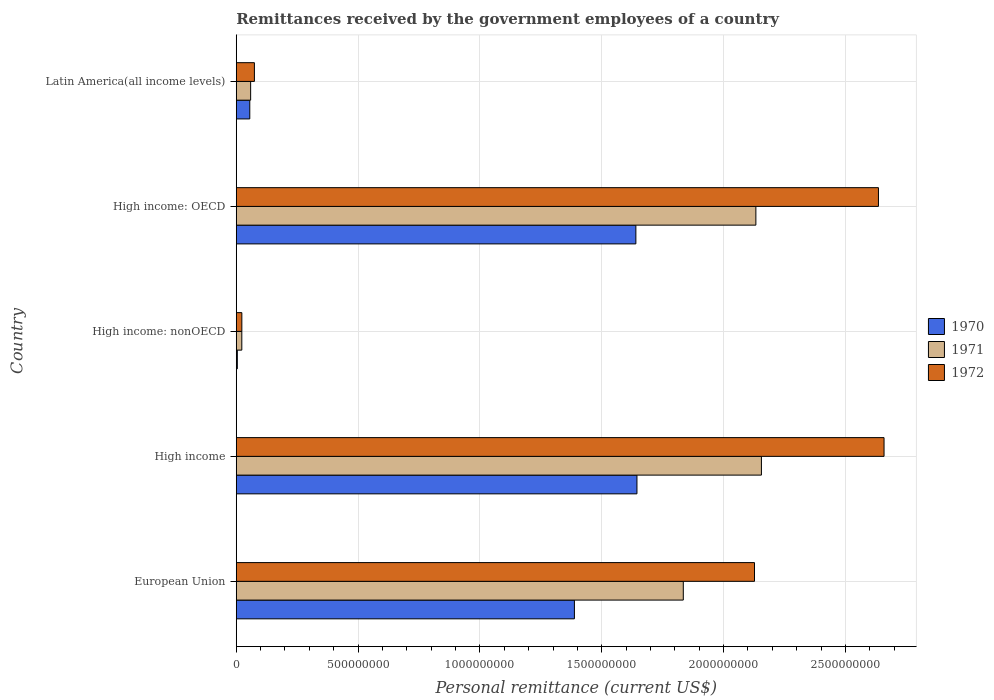How many groups of bars are there?
Provide a short and direct response. 5. Are the number of bars per tick equal to the number of legend labels?
Keep it short and to the point. Yes. How many bars are there on the 2nd tick from the top?
Your answer should be compact. 3. How many bars are there on the 5th tick from the bottom?
Provide a short and direct response. 3. In how many cases, is the number of bars for a given country not equal to the number of legend labels?
Ensure brevity in your answer.  0. What is the remittances received by the government employees in 1971 in Latin America(all income levels)?
Offer a very short reply. 5.91e+07. Across all countries, what is the maximum remittances received by the government employees in 1971?
Offer a very short reply. 2.16e+09. Across all countries, what is the minimum remittances received by the government employees in 1972?
Offer a very short reply. 2.29e+07. In which country was the remittances received by the government employees in 1971 maximum?
Offer a terse response. High income. In which country was the remittances received by the government employees in 1972 minimum?
Give a very brief answer. High income: nonOECD. What is the total remittances received by the government employees in 1971 in the graph?
Make the answer very short. 6.20e+09. What is the difference between the remittances received by the government employees in 1970 in High income and that in Latin America(all income levels)?
Provide a short and direct response. 1.59e+09. What is the difference between the remittances received by the government employees in 1970 in High income and the remittances received by the government employees in 1971 in Latin America(all income levels)?
Offer a terse response. 1.59e+09. What is the average remittances received by the government employees in 1971 per country?
Ensure brevity in your answer.  1.24e+09. What is the difference between the remittances received by the government employees in 1972 and remittances received by the government employees in 1970 in High income: OECD?
Give a very brief answer. 9.96e+08. What is the ratio of the remittances received by the government employees in 1972 in High income to that in Latin America(all income levels)?
Your answer should be very brief. 35.7. Is the difference between the remittances received by the government employees in 1972 in European Union and Latin America(all income levels) greater than the difference between the remittances received by the government employees in 1970 in European Union and Latin America(all income levels)?
Provide a short and direct response. Yes. What is the difference between the highest and the second highest remittances received by the government employees in 1972?
Give a very brief answer. 2.29e+07. What is the difference between the highest and the lowest remittances received by the government employees in 1972?
Give a very brief answer. 2.64e+09. Is the sum of the remittances received by the government employees in 1971 in High income and High income: OECD greater than the maximum remittances received by the government employees in 1972 across all countries?
Make the answer very short. Yes. What does the 1st bar from the bottom in European Union represents?
Offer a terse response. 1970. Is it the case that in every country, the sum of the remittances received by the government employees in 1972 and remittances received by the government employees in 1971 is greater than the remittances received by the government employees in 1970?
Give a very brief answer. Yes. How many bars are there?
Offer a very short reply. 15. Are all the bars in the graph horizontal?
Your answer should be compact. Yes. How many countries are there in the graph?
Offer a terse response. 5. What is the difference between two consecutive major ticks on the X-axis?
Offer a terse response. 5.00e+08. Are the values on the major ticks of X-axis written in scientific E-notation?
Your answer should be very brief. No. Where does the legend appear in the graph?
Offer a terse response. Center right. How many legend labels are there?
Offer a very short reply. 3. How are the legend labels stacked?
Your answer should be compact. Vertical. What is the title of the graph?
Your answer should be compact. Remittances received by the government employees of a country. Does "2001" appear as one of the legend labels in the graph?
Your answer should be compact. No. What is the label or title of the X-axis?
Provide a short and direct response. Personal remittance (current US$). What is the label or title of the Y-axis?
Your answer should be very brief. Country. What is the Personal remittance (current US$) of 1970 in European Union?
Keep it short and to the point. 1.39e+09. What is the Personal remittance (current US$) in 1971 in European Union?
Provide a succinct answer. 1.83e+09. What is the Personal remittance (current US$) of 1972 in European Union?
Provide a succinct answer. 2.13e+09. What is the Personal remittance (current US$) in 1970 in High income?
Provide a short and direct response. 1.64e+09. What is the Personal remittance (current US$) in 1971 in High income?
Offer a terse response. 2.16e+09. What is the Personal remittance (current US$) in 1972 in High income?
Provide a succinct answer. 2.66e+09. What is the Personal remittance (current US$) in 1970 in High income: nonOECD?
Provide a succinct answer. 4.40e+06. What is the Personal remittance (current US$) of 1971 in High income: nonOECD?
Make the answer very short. 2.28e+07. What is the Personal remittance (current US$) in 1972 in High income: nonOECD?
Your answer should be very brief. 2.29e+07. What is the Personal remittance (current US$) of 1970 in High income: OECD?
Ensure brevity in your answer.  1.64e+09. What is the Personal remittance (current US$) in 1971 in High income: OECD?
Your answer should be very brief. 2.13e+09. What is the Personal remittance (current US$) of 1972 in High income: OECD?
Keep it short and to the point. 2.64e+09. What is the Personal remittance (current US$) of 1970 in Latin America(all income levels)?
Ensure brevity in your answer.  5.55e+07. What is the Personal remittance (current US$) of 1971 in Latin America(all income levels)?
Ensure brevity in your answer.  5.91e+07. What is the Personal remittance (current US$) of 1972 in Latin America(all income levels)?
Your response must be concise. 7.45e+07. Across all countries, what is the maximum Personal remittance (current US$) of 1970?
Provide a short and direct response. 1.64e+09. Across all countries, what is the maximum Personal remittance (current US$) in 1971?
Your answer should be very brief. 2.16e+09. Across all countries, what is the maximum Personal remittance (current US$) in 1972?
Your answer should be very brief. 2.66e+09. Across all countries, what is the minimum Personal remittance (current US$) of 1970?
Give a very brief answer. 4.40e+06. Across all countries, what is the minimum Personal remittance (current US$) of 1971?
Make the answer very short. 2.28e+07. Across all countries, what is the minimum Personal remittance (current US$) in 1972?
Your answer should be compact. 2.29e+07. What is the total Personal remittance (current US$) of 1970 in the graph?
Give a very brief answer. 4.73e+09. What is the total Personal remittance (current US$) of 1971 in the graph?
Your answer should be very brief. 6.20e+09. What is the total Personal remittance (current US$) in 1972 in the graph?
Make the answer very short. 7.52e+09. What is the difference between the Personal remittance (current US$) in 1970 in European Union and that in High income?
Offer a terse response. -2.57e+08. What is the difference between the Personal remittance (current US$) of 1971 in European Union and that in High income?
Keep it short and to the point. -3.21e+08. What is the difference between the Personal remittance (current US$) in 1972 in European Union and that in High income?
Provide a succinct answer. -5.32e+08. What is the difference between the Personal remittance (current US$) in 1970 in European Union and that in High income: nonOECD?
Your answer should be very brief. 1.38e+09. What is the difference between the Personal remittance (current US$) of 1971 in European Union and that in High income: nonOECD?
Your answer should be compact. 1.81e+09. What is the difference between the Personal remittance (current US$) in 1972 in European Union and that in High income: nonOECD?
Your answer should be very brief. 2.10e+09. What is the difference between the Personal remittance (current US$) of 1970 in European Union and that in High income: OECD?
Make the answer very short. -2.52e+08. What is the difference between the Personal remittance (current US$) of 1971 in European Union and that in High income: OECD?
Offer a very short reply. -2.98e+08. What is the difference between the Personal remittance (current US$) in 1972 in European Union and that in High income: OECD?
Your answer should be very brief. -5.09e+08. What is the difference between the Personal remittance (current US$) of 1970 in European Union and that in Latin America(all income levels)?
Your answer should be compact. 1.33e+09. What is the difference between the Personal remittance (current US$) of 1971 in European Union and that in Latin America(all income levels)?
Ensure brevity in your answer.  1.78e+09. What is the difference between the Personal remittance (current US$) in 1972 in European Union and that in Latin America(all income levels)?
Give a very brief answer. 2.05e+09. What is the difference between the Personal remittance (current US$) in 1970 in High income and that in High income: nonOECD?
Ensure brevity in your answer.  1.64e+09. What is the difference between the Personal remittance (current US$) in 1971 in High income and that in High income: nonOECD?
Your answer should be very brief. 2.13e+09. What is the difference between the Personal remittance (current US$) in 1972 in High income and that in High income: nonOECD?
Offer a terse response. 2.64e+09. What is the difference between the Personal remittance (current US$) in 1970 in High income and that in High income: OECD?
Offer a terse response. 4.40e+06. What is the difference between the Personal remittance (current US$) of 1971 in High income and that in High income: OECD?
Give a very brief answer. 2.28e+07. What is the difference between the Personal remittance (current US$) of 1972 in High income and that in High income: OECD?
Your answer should be very brief. 2.29e+07. What is the difference between the Personal remittance (current US$) in 1970 in High income and that in Latin America(all income levels)?
Make the answer very short. 1.59e+09. What is the difference between the Personal remittance (current US$) of 1971 in High income and that in Latin America(all income levels)?
Provide a short and direct response. 2.10e+09. What is the difference between the Personal remittance (current US$) in 1972 in High income and that in Latin America(all income levels)?
Make the answer very short. 2.58e+09. What is the difference between the Personal remittance (current US$) of 1970 in High income: nonOECD and that in High income: OECD?
Ensure brevity in your answer.  -1.64e+09. What is the difference between the Personal remittance (current US$) of 1971 in High income: nonOECD and that in High income: OECD?
Offer a very short reply. -2.11e+09. What is the difference between the Personal remittance (current US$) in 1972 in High income: nonOECD and that in High income: OECD?
Make the answer very short. -2.61e+09. What is the difference between the Personal remittance (current US$) in 1970 in High income: nonOECD and that in Latin America(all income levels)?
Your answer should be very brief. -5.11e+07. What is the difference between the Personal remittance (current US$) in 1971 in High income: nonOECD and that in Latin America(all income levels)?
Offer a terse response. -3.63e+07. What is the difference between the Personal remittance (current US$) in 1972 in High income: nonOECD and that in Latin America(all income levels)?
Ensure brevity in your answer.  -5.16e+07. What is the difference between the Personal remittance (current US$) of 1970 in High income: OECD and that in Latin America(all income levels)?
Give a very brief answer. 1.58e+09. What is the difference between the Personal remittance (current US$) of 1971 in High income: OECD and that in Latin America(all income levels)?
Provide a succinct answer. 2.07e+09. What is the difference between the Personal remittance (current US$) in 1972 in High income: OECD and that in Latin America(all income levels)?
Provide a succinct answer. 2.56e+09. What is the difference between the Personal remittance (current US$) of 1970 in European Union and the Personal remittance (current US$) of 1971 in High income?
Offer a terse response. -7.68e+08. What is the difference between the Personal remittance (current US$) of 1970 in European Union and the Personal remittance (current US$) of 1972 in High income?
Your answer should be compact. -1.27e+09. What is the difference between the Personal remittance (current US$) of 1971 in European Union and the Personal remittance (current US$) of 1972 in High income?
Provide a short and direct response. -8.24e+08. What is the difference between the Personal remittance (current US$) in 1970 in European Union and the Personal remittance (current US$) in 1971 in High income: nonOECD?
Make the answer very short. 1.37e+09. What is the difference between the Personal remittance (current US$) in 1970 in European Union and the Personal remittance (current US$) in 1972 in High income: nonOECD?
Keep it short and to the point. 1.36e+09. What is the difference between the Personal remittance (current US$) of 1971 in European Union and the Personal remittance (current US$) of 1972 in High income: nonOECD?
Make the answer very short. 1.81e+09. What is the difference between the Personal remittance (current US$) in 1970 in European Union and the Personal remittance (current US$) in 1971 in High income: OECD?
Your answer should be very brief. -7.45e+08. What is the difference between the Personal remittance (current US$) of 1970 in European Union and the Personal remittance (current US$) of 1972 in High income: OECD?
Offer a very short reply. -1.25e+09. What is the difference between the Personal remittance (current US$) in 1971 in European Union and the Personal remittance (current US$) in 1972 in High income: OECD?
Offer a very short reply. -8.01e+08. What is the difference between the Personal remittance (current US$) of 1970 in European Union and the Personal remittance (current US$) of 1971 in Latin America(all income levels)?
Your answer should be compact. 1.33e+09. What is the difference between the Personal remittance (current US$) in 1970 in European Union and the Personal remittance (current US$) in 1972 in Latin America(all income levels)?
Offer a terse response. 1.31e+09. What is the difference between the Personal remittance (current US$) of 1971 in European Union and the Personal remittance (current US$) of 1972 in Latin America(all income levels)?
Offer a very short reply. 1.76e+09. What is the difference between the Personal remittance (current US$) of 1970 in High income and the Personal remittance (current US$) of 1971 in High income: nonOECD?
Offer a terse response. 1.62e+09. What is the difference between the Personal remittance (current US$) of 1970 in High income and the Personal remittance (current US$) of 1972 in High income: nonOECD?
Provide a short and direct response. 1.62e+09. What is the difference between the Personal remittance (current US$) of 1971 in High income and the Personal remittance (current US$) of 1972 in High income: nonOECD?
Ensure brevity in your answer.  2.13e+09. What is the difference between the Personal remittance (current US$) in 1970 in High income and the Personal remittance (current US$) in 1971 in High income: OECD?
Offer a very short reply. -4.88e+08. What is the difference between the Personal remittance (current US$) of 1970 in High income and the Personal remittance (current US$) of 1972 in High income: OECD?
Your response must be concise. -9.91e+08. What is the difference between the Personal remittance (current US$) in 1971 in High income and the Personal remittance (current US$) in 1972 in High income: OECD?
Your answer should be very brief. -4.80e+08. What is the difference between the Personal remittance (current US$) in 1970 in High income and the Personal remittance (current US$) in 1971 in Latin America(all income levels)?
Give a very brief answer. 1.59e+09. What is the difference between the Personal remittance (current US$) of 1970 in High income and the Personal remittance (current US$) of 1972 in Latin America(all income levels)?
Ensure brevity in your answer.  1.57e+09. What is the difference between the Personal remittance (current US$) in 1971 in High income and the Personal remittance (current US$) in 1972 in Latin America(all income levels)?
Provide a short and direct response. 2.08e+09. What is the difference between the Personal remittance (current US$) of 1970 in High income: nonOECD and the Personal remittance (current US$) of 1971 in High income: OECD?
Offer a terse response. -2.13e+09. What is the difference between the Personal remittance (current US$) in 1970 in High income: nonOECD and the Personal remittance (current US$) in 1972 in High income: OECD?
Your answer should be compact. -2.63e+09. What is the difference between the Personal remittance (current US$) of 1971 in High income: nonOECD and the Personal remittance (current US$) of 1972 in High income: OECD?
Give a very brief answer. -2.61e+09. What is the difference between the Personal remittance (current US$) in 1970 in High income: nonOECD and the Personal remittance (current US$) in 1971 in Latin America(all income levels)?
Offer a terse response. -5.47e+07. What is the difference between the Personal remittance (current US$) of 1970 in High income: nonOECD and the Personal remittance (current US$) of 1972 in Latin America(all income levels)?
Provide a short and direct response. -7.01e+07. What is the difference between the Personal remittance (current US$) in 1971 in High income: nonOECD and the Personal remittance (current US$) in 1972 in Latin America(all income levels)?
Give a very brief answer. -5.17e+07. What is the difference between the Personal remittance (current US$) in 1970 in High income: OECD and the Personal remittance (current US$) in 1971 in Latin America(all income levels)?
Make the answer very short. 1.58e+09. What is the difference between the Personal remittance (current US$) of 1970 in High income: OECD and the Personal remittance (current US$) of 1972 in Latin America(all income levels)?
Keep it short and to the point. 1.57e+09. What is the difference between the Personal remittance (current US$) in 1971 in High income: OECD and the Personal remittance (current US$) in 1972 in Latin America(all income levels)?
Offer a very short reply. 2.06e+09. What is the average Personal remittance (current US$) in 1970 per country?
Ensure brevity in your answer.  9.46e+08. What is the average Personal remittance (current US$) in 1971 per country?
Give a very brief answer. 1.24e+09. What is the average Personal remittance (current US$) of 1972 per country?
Ensure brevity in your answer.  1.50e+09. What is the difference between the Personal remittance (current US$) in 1970 and Personal remittance (current US$) in 1971 in European Union?
Your response must be concise. -4.47e+08. What is the difference between the Personal remittance (current US$) of 1970 and Personal remittance (current US$) of 1972 in European Union?
Offer a terse response. -7.39e+08. What is the difference between the Personal remittance (current US$) of 1971 and Personal remittance (current US$) of 1972 in European Union?
Give a very brief answer. -2.92e+08. What is the difference between the Personal remittance (current US$) in 1970 and Personal remittance (current US$) in 1971 in High income?
Your response must be concise. -5.11e+08. What is the difference between the Personal remittance (current US$) of 1970 and Personal remittance (current US$) of 1972 in High income?
Offer a very short reply. -1.01e+09. What is the difference between the Personal remittance (current US$) of 1971 and Personal remittance (current US$) of 1972 in High income?
Your response must be concise. -5.03e+08. What is the difference between the Personal remittance (current US$) in 1970 and Personal remittance (current US$) in 1971 in High income: nonOECD?
Provide a succinct answer. -1.84e+07. What is the difference between the Personal remittance (current US$) in 1970 and Personal remittance (current US$) in 1972 in High income: nonOECD?
Keep it short and to the point. -1.85e+07. What is the difference between the Personal remittance (current US$) of 1971 and Personal remittance (current US$) of 1972 in High income: nonOECD?
Give a very brief answer. -1.37e+05. What is the difference between the Personal remittance (current US$) of 1970 and Personal remittance (current US$) of 1971 in High income: OECD?
Make the answer very short. -4.92e+08. What is the difference between the Personal remittance (current US$) of 1970 and Personal remittance (current US$) of 1972 in High income: OECD?
Give a very brief answer. -9.96e+08. What is the difference between the Personal remittance (current US$) in 1971 and Personal remittance (current US$) in 1972 in High income: OECD?
Offer a very short reply. -5.03e+08. What is the difference between the Personal remittance (current US$) of 1970 and Personal remittance (current US$) of 1971 in Latin America(all income levels)?
Provide a short and direct response. -3.57e+06. What is the difference between the Personal remittance (current US$) in 1970 and Personal remittance (current US$) in 1972 in Latin America(all income levels)?
Keep it short and to the point. -1.90e+07. What is the difference between the Personal remittance (current US$) of 1971 and Personal remittance (current US$) of 1972 in Latin America(all income levels)?
Offer a terse response. -1.54e+07. What is the ratio of the Personal remittance (current US$) in 1970 in European Union to that in High income?
Offer a very short reply. 0.84. What is the ratio of the Personal remittance (current US$) of 1971 in European Union to that in High income?
Give a very brief answer. 0.85. What is the ratio of the Personal remittance (current US$) in 1970 in European Union to that in High income: nonOECD?
Make the answer very short. 315.41. What is the ratio of the Personal remittance (current US$) of 1971 in European Union to that in High income: nonOECD?
Ensure brevity in your answer.  80.52. What is the ratio of the Personal remittance (current US$) of 1972 in European Union to that in High income: nonOECD?
Offer a very short reply. 92.79. What is the ratio of the Personal remittance (current US$) of 1970 in European Union to that in High income: OECD?
Ensure brevity in your answer.  0.85. What is the ratio of the Personal remittance (current US$) in 1971 in European Union to that in High income: OECD?
Provide a succinct answer. 0.86. What is the ratio of the Personal remittance (current US$) of 1972 in European Union to that in High income: OECD?
Your answer should be compact. 0.81. What is the ratio of the Personal remittance (current US$) of 1970 in European Union to that in Latin America(all income levels)?
Make the answer very short. 25.01. What is the ratio of the Personal remittance (current US$) in 1971 in European Union to that in Latin America(all income levels)?
Your response must be concise. 31.06. What is the ratio of the Personal remittance (current US$) in 1972 in European Union to that in Latin America(all income levels)?
Ensure brevity in your answer.  28.56. What is the ratio of the Personal remittance (current US$) in 1970 in High income to that in High income: nonOECD?
Your answer should be very brief. 373.75. What is the ratio of the Personal remittance (current US$) of 1971 in High income to that in High income: nonOECD?
Ensure brevity in your answer.  94.6. What is the ratio of the Personal remittance (current US$) of 1972 in High income to that in High income: nonOECD?
Your answer should be compact. 115.99. What is the ratio of the Personal remittance (current US$) in 1971 in High income to that in High income: OECD?
Offer a very short reply. 1.01. What is the ratio of the Personal remittance (current US$) of 1972 in High income to that in High income: OECD?
Make the answer very short. 1.01. What is the ratio of the Personal remittance (current US$) of 1970 in High income to that in Latin America(all income levels)?
Your response must be concise. 29.63. What is the ratio of the Personal remittance (current US$) of 1971 in High income to that in Latin America(all income levels)?
Keep it short and to the point. 36.49. What is the ratio of the Personal remittance (current US$) in 1972 in High income to that in Latin America(all income levels)?
Keep it short and to the point. 35.7. What is the ratio of the Personal remittance (current US$) of 1970 in High income: nonOECD to that in High income: OECD?
Offer a terse response. 0. What is the ratio of the Personal remittance (current US$) of 1971 in High income: nonOECD to that in High income: OECD?
Make the answer very short. 0.01. What is the ratio of the Personal remittance (current US$) in 1972 in High income: nonOECD to that in High income: OECD?
Provide a succinct answer. 0.01. What is the ratio of the Personal remittance (current US$) in 1970 in High income: nonOECD to that in Latin America(all income levels)?
Ensure brevity in your answer.  0.08. What is the ratio of the Personal remittance (current US$) of 1971 in High income: nonOECD to that in Latin America(all income levels)?
Offer a terse response. 0.39. What is the ratio of the Personal remittance (current US$) in 1972 in High income: nonOECD to that in Latin America(all income levels)?
Your response must be concise. 0.31. What is the ratio of the Personal remittance (current US$) of 1970 in High income: OECD to that in Latin America(all income levels)?
Your answer should be compact. 29.55. What is the ratio of the Personal remittance (current US$) in 1971 in High income: OECD to that in Latin America(all income levels)?
Ensure brevity in your answer.  36.1. What is the ratio of the Personal remittance (current US$) of 1972 in High income: OECD to that in Latin America(all income levels)?
Provide a short and direct response. 35.39. What is the difference between the highest and the second highest Personal remittance (current US$) in 1970?
Your answer should be compact. 4.40e+06. What is the difference between the highest and the second highest Personal remittance (current US$) in 1971?
Offer a very short reply. 2.28e+07. What is the difference between the highest and the second highest Personal remittance (current US$) of 1972?
Ensure brevity in your answer.  2.29e+07. What is the difference between the highest and the lowest Personal remittance (current US$) of 1970?
Make the answer very short. 1.64e+09. What is the difference between the highest and the lowest Personal remittance (current US$) of 1971?
Offer a very short reply. 2.13e+09. What is the difference between the highest and the lowest Personal remittance (current US$) in 1972?
Your response must be concise. 2.64e+09. 